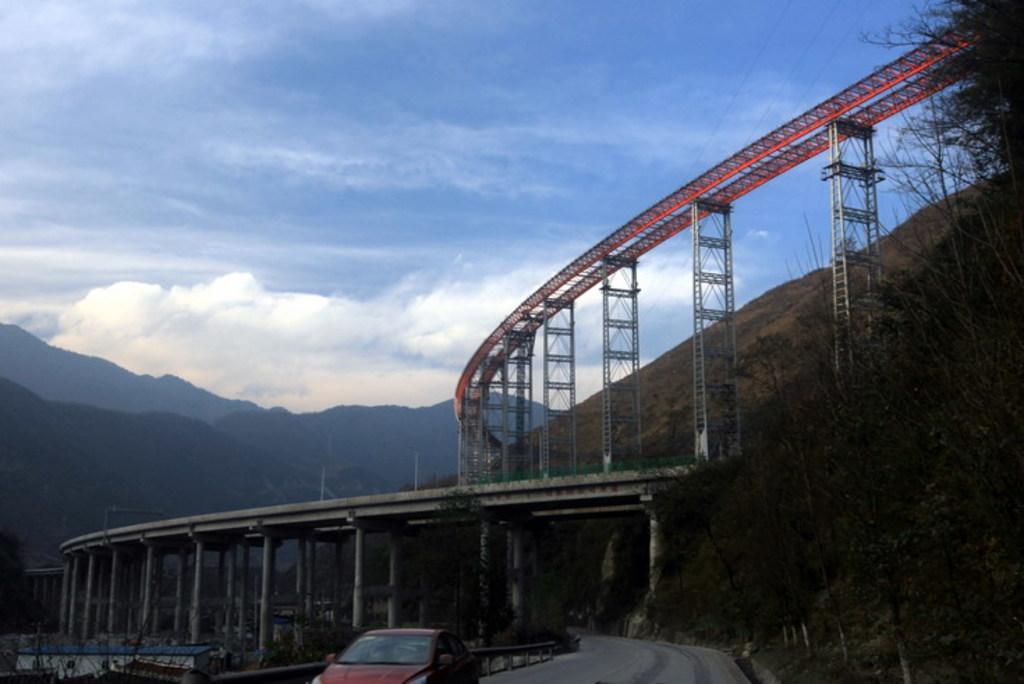Describe this image in one or two sentences. In this picture there is a car and a bridge at the bottom side of the image and there are trees on the right and left side of the image, there are towers in the center of the image. 